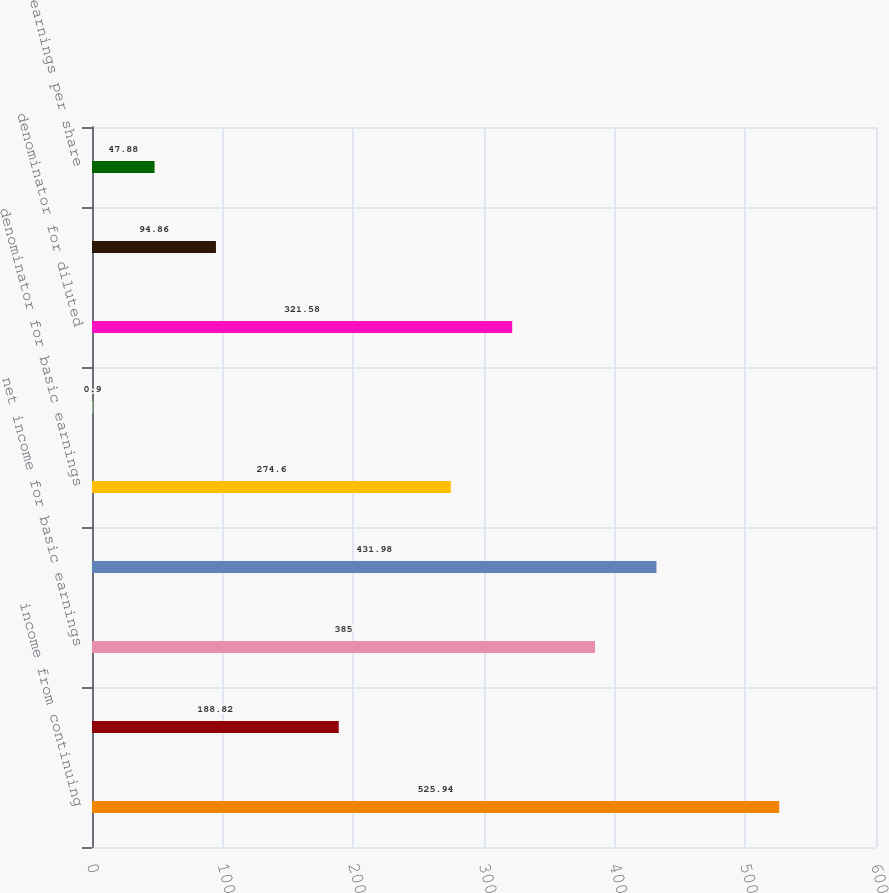Convert chart to OTSL. <chart><loc_0><loc_0><loc_500><loc_500><bar_chart><fcel>income from continuing<fcel>loss from discontinued<fcel>net income for basic earnings<fcel>net income for diluted<fcel>denominator for basic earnings<fcel>dilutive securities (2)<fcel>denominator for diluted<fcel>basic earnings (loss) per<fcel>earnings per share<nl><fcel>525.94<fcel>188.82<fcel>385<fcel>431.98<fcel>274.6<fcel>0.9<fcel>321.58<fcel>94.86<fcel>47.88<nl></chart> 